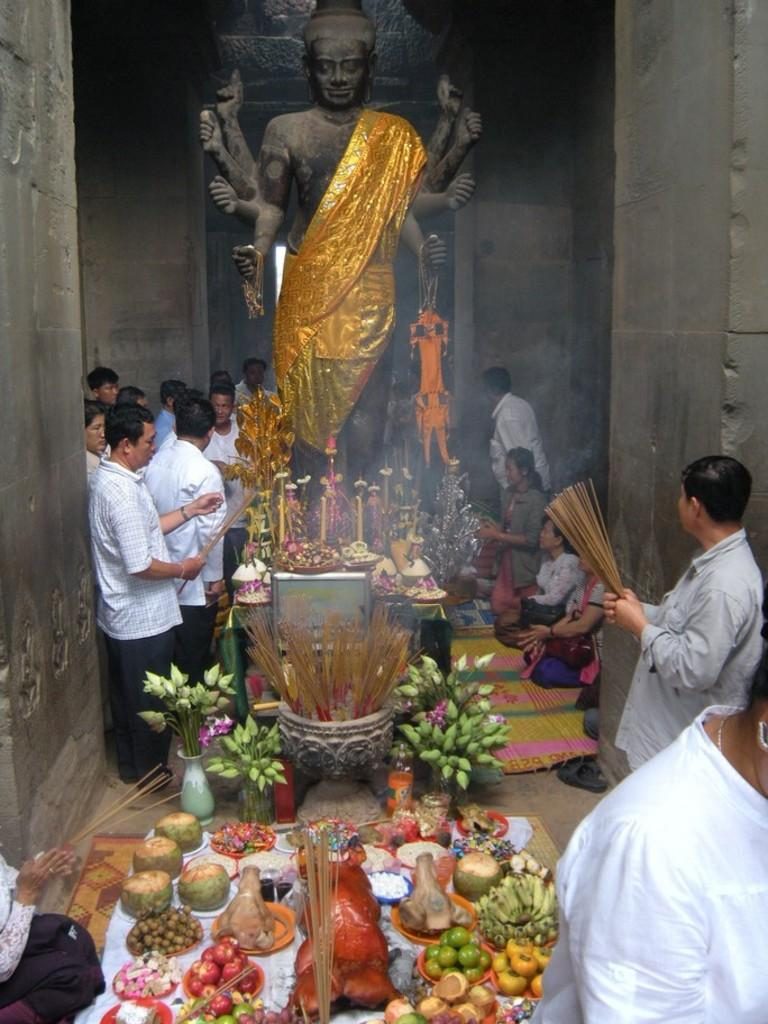What is the main subject of the image? There is a statue of a god in the image. Are there any people present in the image? Yes, there are people in the image. What other items can be seen in the image besides the statue and people? There are fruits and mats in the image. Can you describe any other objects present in the image? There are other objects in the image, but their specific details are not mentioned in the provided facts. How does the statue of the god cough in the image? The statue of the god does not cough in the image, as it is an inanimate object and cannot perform such actions. 